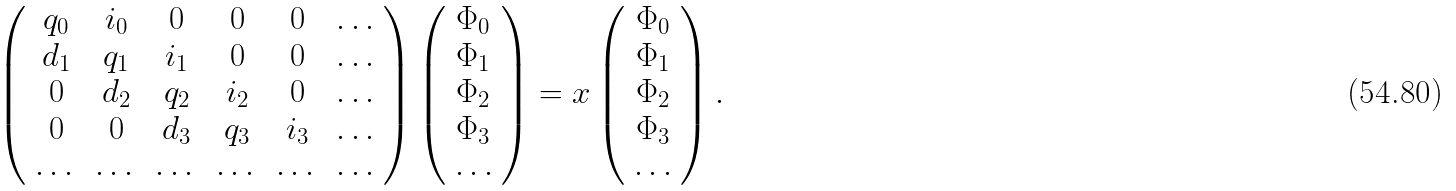Convert formula to latex. <formula><loc_0><loc_0><loc_500><loc_500>\left ( \begin{array} { c c c c c c } q _ { 0 } & i _ { 0 } & 0 & 0 & 0 & \dots \\ d _ { 1 } & q _ { 1 } & i _ { 1 } & 0 & 0 & \dots \\ 0 & d _ { 2 } & q _ { 2 } & i _ { 2 } & 0 & \dots \\ 0 & 0 & d _ { 3 } & q _ { 3 } & i _ { 3 } & \dots \\ \dots & \dots & \dots & \dots & \dots & \dots \end{array} \right ) \left ( \begin{array} { c } \Phi _ { 0 } \\ \Phi _ { 1 } \\ \Phi _ { 2 } \\ \Phi _ { 3 } \\ \dots \end{array} \right ) = x \left ( \begin{array} { c } \Phi _ { 0 } \\ \Phi _ { 1 } \\ \Phi _ { 2 } \\ \Phi _ { 3 } \\ \dots \end{array} \right ) .</formula> 